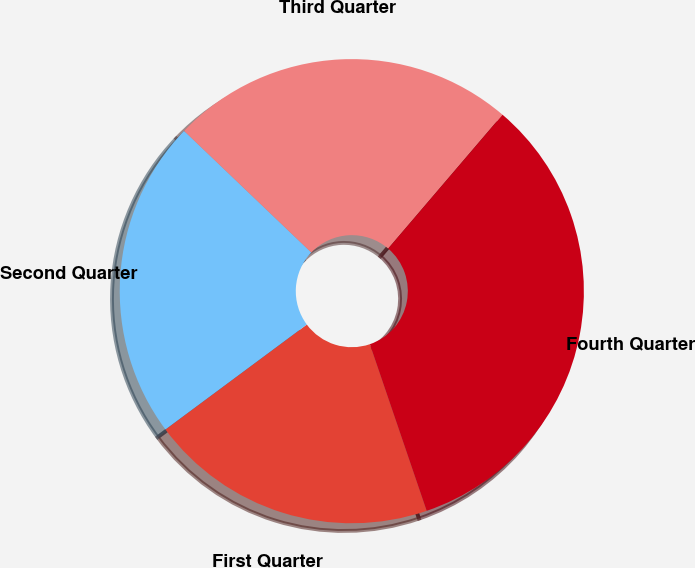Convert chart. <chart><loc_0><loc_0><loc_500><loc_500><pie_chart><fcel>First Quarter<fcel>Second Quarter<fcel>Third Quarter<fcel>Fourth Quarter<nl><fcel>20.07%<fcel>22.3%<fcel>24.11%<fcel>33.52%<nl></chart> 